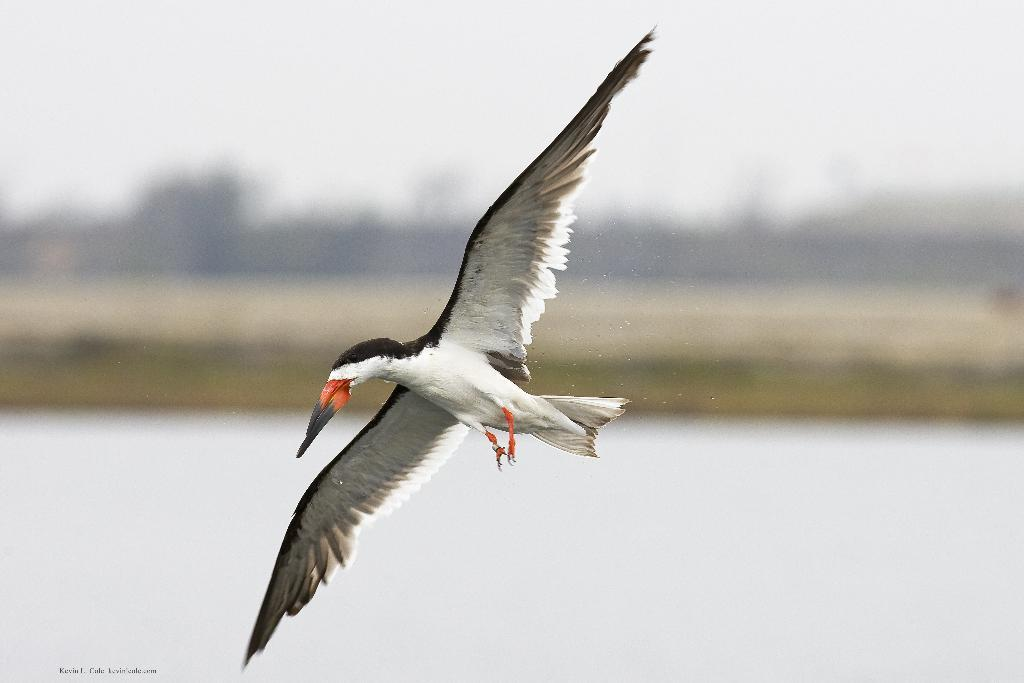What animal can be seen in the image? There is a bird in the image. What is the bird doing in the image? The bird is flying. What colors can be observed on the bird? The bird is white and black in color. What natural elements are visible in the image? Water and trees can be seen in the image. Where is the text located in the image? The text is at the bottom left corner of the image. Can you tell me how many ovens are visible in the image? There are no ovens present in the image. What type of cave can be seen in the image? There is no cave present in the image. 